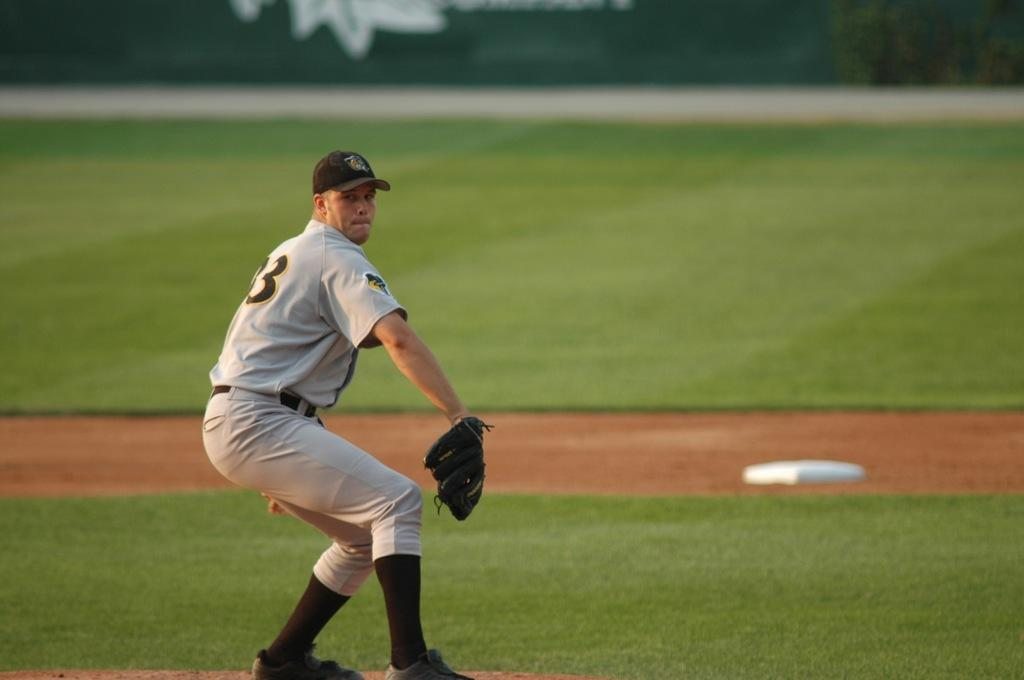What is the man in the image wearing on his upper body? The man is wearing a T-shirt in the image. What is the man wearing on his lower body? The man is wearing trousers in the image. What type of footwear is the man wearing? The man is wearing shoes in the image. What headgear is the man wearing? The man is wearing a cap in the image. What accessory is the man wearing on his hand? The man is wearing a baseball glove in the image. Where might the image have been taken? The image appears to be taken at a baseball ground. What can be seen in the background of the image? There is a hoarding visible in the background of the image. What type of stew is the man eating in the image? There is no stew present in the image; the man is wearing a baseball glove and appears to be at a baseball ground. What degree does the man have in the image? There is no information about the man's degree in the image. 